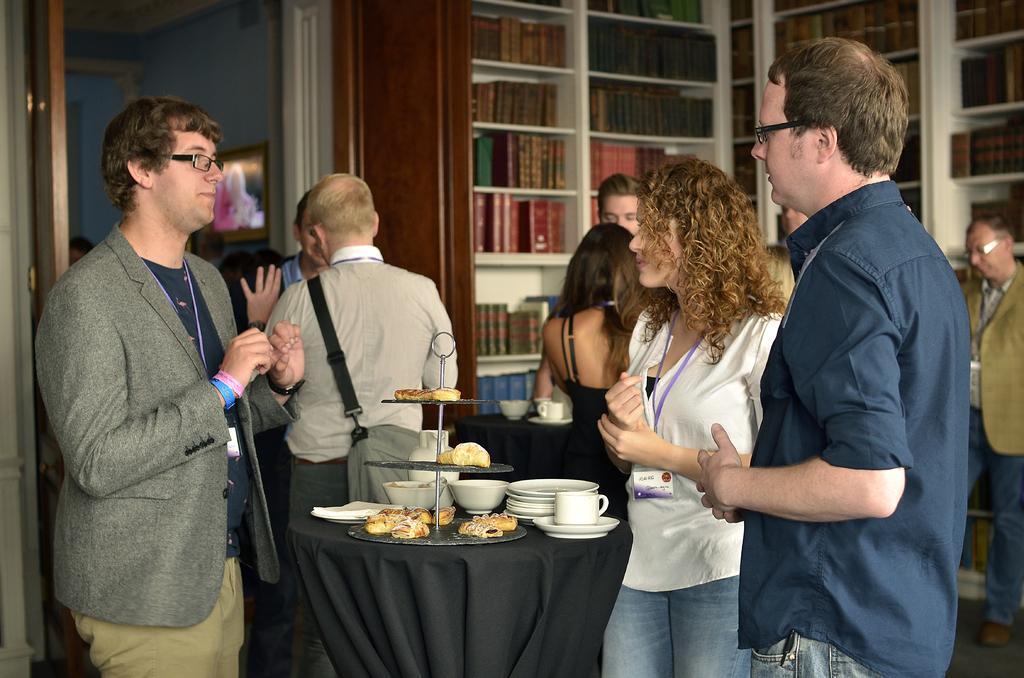In one or two sentences, can you explain what this image depicts? In the picture we can see two men and a woman are standing and talking to each other they are wearing ID cards with purple color tag and beside them we can see a table with black color table cloth on it we can see cup and saucer, some plates, some food items and some food items on the stand and behind it we can see some people are standing and talking and behind them we can see a book rack with full of books in it and beside it we can see another room with door. 